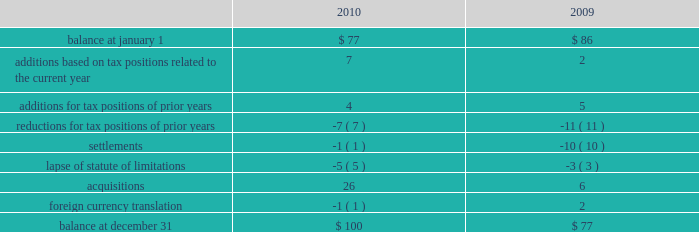Remitted to the u.s .
Due to foreign tax credits and exclusions that may become available at the time of remittance .
At december 31 , 2010 , aon had domestic federal operating loss carryforwards of $ 56 million that will expire at various dates from 2011 to 2024 , state operating loss carryforwards of $ 610 million that will expire at various dates from 2011 to 2031 , and foreign operating and capital loss carryforwards of $ 720 million and $ 251 million , respectively , nearly all of which are subject to indefinite carryforward .
Unrecognized tax provisions the following is a reconciliation of the company 2019s beginning and ending amount of unrecognized tax benefits ( in millions ) : .
As of december 31 , 2010 , $ 85 million of unrecognized tax benefits would impact the effective tax rate if recognized .
Aon does not expect the unrecognized tax positions to change significantly over the next twelve months , except for a potential reduction of unrecognized tax benefits in the range of $ 10-$ 15 million relating to anticipated audit settlements .
The company recognizes penalties and interest related to unrecognized income tax benefits in its provision for income taxes .
Aon accrued potential penalties of less than $ 1 million during each of 2010 , 2009 and 2008 .
Aon accrued interest of less than $ 1 million in 2010 , $ 2 million during 2009 and less than $ 1 million in 2008 .
Aon has recorded a liability for penalties of $ 5 million and for interest of $ 18 million for both december 31 , 2010 and 2009 .
Aon and its subsidiaries file income tax returns in the u.s .
Federal jurisdiction as well as various state and international jurisdictions .
Aon has substantially concluded all u.s .
Federal income tax matters for years through 2006 .
Material u.s .
State and local income tax jurisdiction examinations have been concluded for years through 2002 .
Aon has concluded income tax examinations in its primary international jurisdictions through 2004. .
What is the net change in unrecognized tax in 2010? 
Computations: (100 - 77)
Answer: 23.0. 